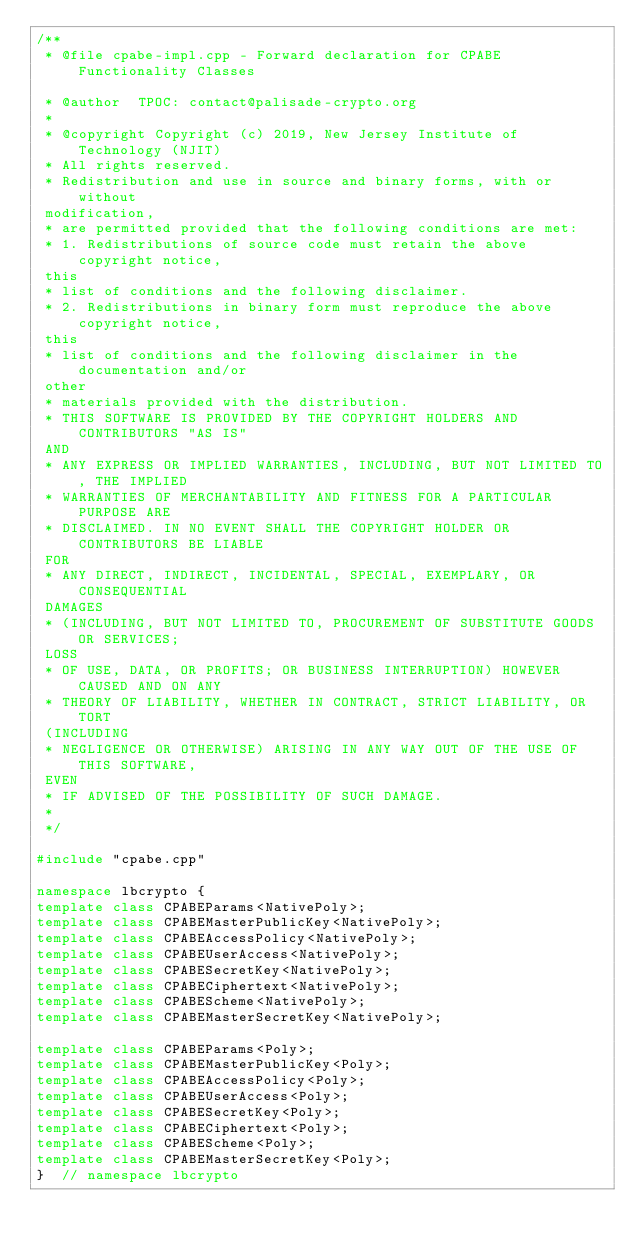<code> <loc_0><loc_0><loc_500><loc_500><_C++_>/**
 * @file cpabe-impl.cpp - Forward declaration for CPABE Functionality Classes

 * @author  TPOC: contact@palisade-crypto.org
 *
 * @copyright Copyright (c) 2019, New Jersey Institute of Technology (NJIT)
 * All rights reserved.
 * Redistribution and use in source and binary forms, with or without
 modification,
 * are permitted provided that the following conditions are met:
 * 1. Redistributions of source code must retain the above copyright notice,
 this
 * list of conditions and the following disclaimer.
 * 2. Redistributions in binary form must reproduce the above copyright notice,
 this
 * list of conditions and the following disclaimer in the documentation and/or
 other
 * materials provided with the distribution.
 * THIS SOFTWARE IS PROVIDED BY THE COPYRIGHT HOLDERS AND CONTRIBUTORS "AS IS"
 AND
 * ANY EXPRESS OR IMPLIED WARRANTIES, INCLUDING, BUT NOT LIMITED TO, THE IMPLIED
 * WARRANTIES OF MERCHANTABILITY AND FITNESS FOR A PARTICULAR PURPOSE ARE
 * DISCLAIMED. IN NO EVENT SHALL THE COPYRIGHT HOLDER OR CONTRIBUTORS BE LIABLE
 FOR
 * ANY DIRECT, INDIRECT, INCIDENTAL, SPECIAL, EXEMPLARY, OR CONSEQUENTIAL
 DAMAGES
 * (INCLUDING, BUT NOT LIMITED TO, PROCUREMENT OF SUBSTITUTE GOODS OR SERVICES;
 LOSS
 * OF USE, DATA, OR PROFITS; OR BUSINESS INTERRUPTION) HOWEVER CAUSED AND ON ANY
 * THEORY OF LIABILITY, WHETHER IN CONTRACT, STRICT LIABILITY, OR TORT
 (INCLUDING
 * NEGLIGENCE OR OTHERWISE) ARISING IN ANY WAY OUT OF THE USE OF THIS SOFTWARE,
 EVEN
 * IF ADVISED OF THE POSSIBILITY OF SUCH DAMAGE.
 *
 */

#include "cpabe.cpp"

namespace lbcrypto {
template class CPABEParams<NativePoly>;
template class CPABEMasterPublicKey<NativePoly>;
template class CPABEAccessPolicy<NativePoly>;
template class CPABEUserAccess<NativePoly>;
template class CPABESecretKey<NativePoly>;
template class CPABECiphertext<NativePoly>;
template class CPABEScheme<NativePoly>;
template class CPABEMasterSecretKey<NativePoly>;

template class CPABEParams<Poly>;
template class CPABEMasterPublicKey<Poly>;
template class CPABEAccessPolicy<Poly>;
template class CPABEUserAccess<Poly>;
template class CPABESecretKey<Poly>;
template class CPABECiphertext<Poly>;
template class CPABEScheme<Poly>;
template class CPABEMasterSecretKey<Poly>;
}  // namespace lbcrypto
</code> 